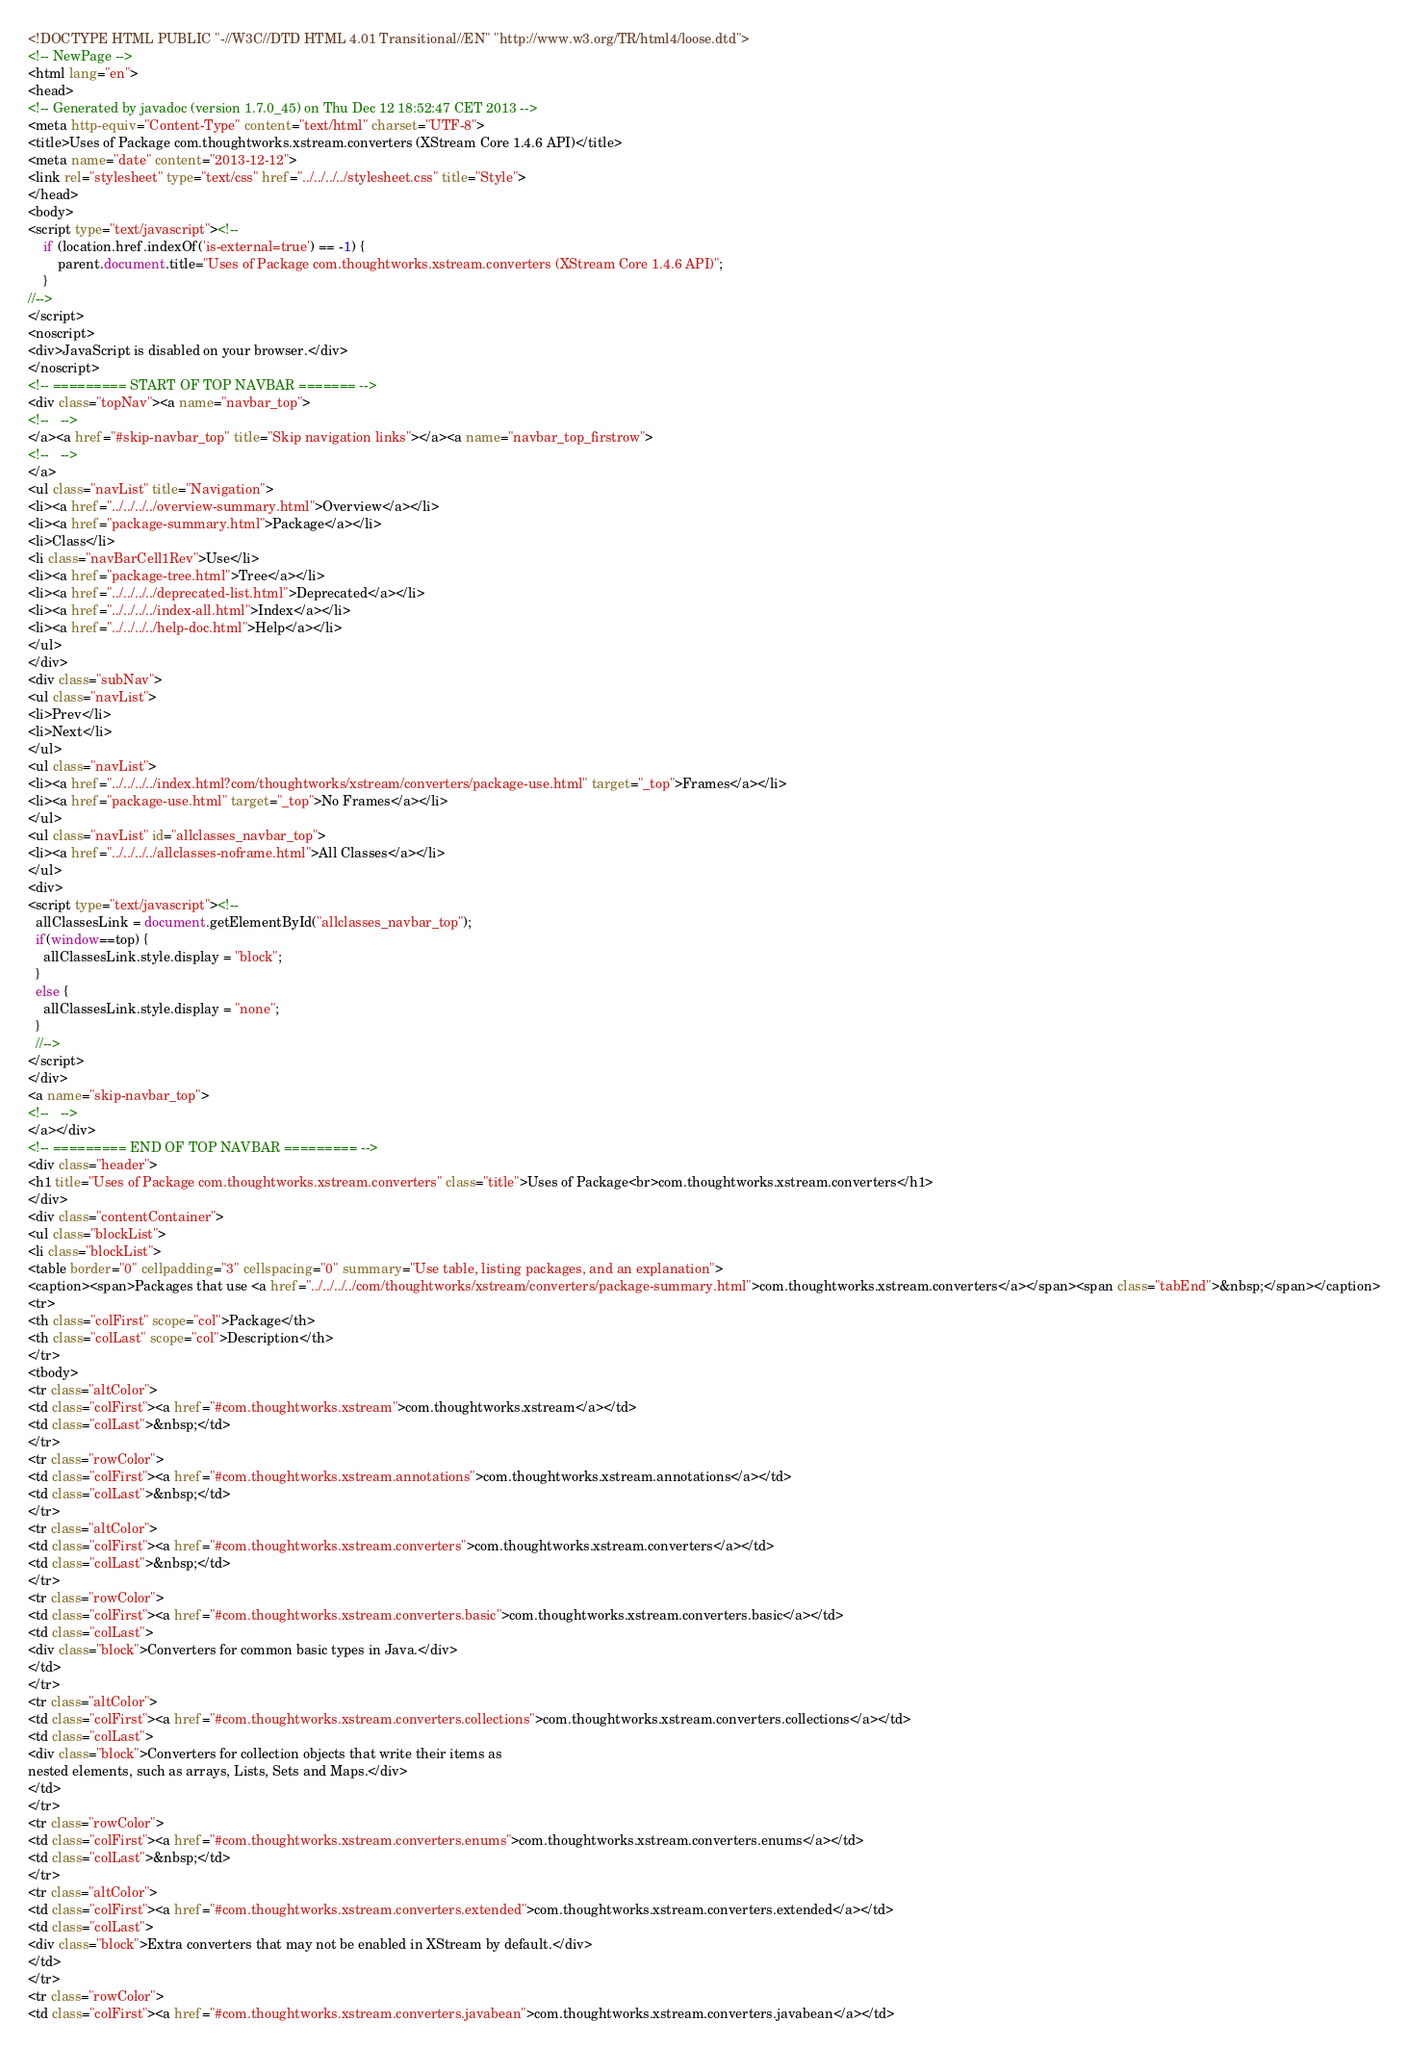Convert code to text. <code><loc_0><loc_0><loc_500><loc_500><_HTML_><!DOCTYPE HTML PUBLIC "-//W3C//DTD HTML 4.01 Transitional//EN" "http://www.w3.org/TR/html4/loose.dtd">
<!-- NewPage -->
<html lang="en">
<head>
<!-- Generated by javadoc (version 1.7.0_45) on Thu Dec 12 18:52:47 CET 2013 -->
<meta http-equiv="Content-Type" content="text/html" charset="UTF-8">
<title>Uses of Package com.thoughtworks.xstream.converters (XStream Core 1.4.6 API)</title>
<meta name="date" content="2013-12-12">
<link rel="stylesheet" type="text/css" href="../../../../stylesheet.css" title="Style">
</head>
<body>
<script type="text/javascript"><!--
    if (location.href.indexOf('is-external=true') == -1) {
        parent.document.title="Uses of Package com.thoughtworks.xstream.converters (XStream Core 1.4.6 API)";
    }
//-->
</script>
<noscript>
<div>JavaScript is disabled on your browser.</div>
</noscript>
<!-- ========= START OF TOP NAVBAR ======= -->
<div class="topNav"><a name="navbar_top">
<!--   -->
</a><a href="#skip-navbar_top" title="Skip navigation links"></a><a name="navbar_top_firstrow">
<!--   -->
</a>
<ul class="navList" title="Navigation">
<li><a href="../../../../overview-summary.html">Overview</a></li>
<li><a href="package-summary.html">Package</a></li>
<li>Class</li>
<li class="navBarCell1Rev">Use</li>
<li><a href="package-tree.html">Tree</a></li>
<li><a href="../../../../deprecated-list.html">Deprecated</a></li>
<li><a href="../../../../index-all.html">Index</a></li>
<li><a href="../../../../help-doc.html">Help</a></li>
</ul>
</div>
<div class="subNav">
<ul class="navList">
<li>Prev</li>
<li>Next</li>
</ul>
<ul class="navList">
<li><a href="../../../../index.html?com/thoughtworks/xstream/converters/package-use.html" target="_top">Frames</a></li>
<li><a href="package-use.html" target="_top">No Frames</a></li>
</ul>
<ul class="navList" id="allclasses_navbar_top">
<li><a href="../../../../allclasses-noframe.html">All Classes</a></li>
</ul>
<div>
<script type="text/javascript"><!--
  allClassesLink = document.getElementById("allclasses_navbar_top");
  if(window==top) {
    allClassesLink.style.display = "block";
  }
  else {
    allClassesLink.style.display = "none";
  }
  //-->
</script>
</div>
<a name="skip-navbar_top">
<!--   -->
</a></div>
<!-- ========= END OF TOP NAVBAR ========= -->
<div class="header">
<h1 title="Uses of Package com.thoughtworks.xstream.converters" class="title">Uses of Package<br>com.thoughtworks.xstream.converters</h1>
</div>
<div class="contentContainer">
<ul class="blockList">
<li class="blockList">
<table border="0" cellpadding="3" cellspacing="0" summary="Use table, listing packages, and an explanation">
<caption><span>Packages that use <a href="../../../../com/thoughtworks/xstream/converters/package-summary.html">com.thoughtworks.xstream.converters</a></span><span class="tabEnd">&nbsp;</span></caption>
<tr>
<th class="colFirst" scope="col">Package</th>
<th class="colLast" scope="col">Description</th>
</tr>
<tbody>
<tr class="altColor">
<td class="colFirst"><a href="#com.thoughtworks.xstream">com.thoughtworks.xstream</a></td>
<td class="colLast">&nbsp;</td>
</tr>
<tr class="rowColor">
<td class="colFirst"><a href="#com.thoughtworks.xstream.annotations">com.thoughtworks.xstream.annotations</a></td>
<td class="colLast">&nbsp;</td>
</tr>
<tr class="altColor">
<td class="colFirst"><a href="#com.thoughtworks.xstream.converters">com.thoughtworks.xstream.converters</a></td>
<td class="colLast">&nbsp;</td>
</tr>
<tr class="rowColor">
<td class="colFirst"><a href="#com.thoughtworks.xstream.converters.basic">com.thoughtworks.xstream.converters.basic</a></td>
<td class="colLast">
<div class="block">Converters for common basic types in Java.</div>
</td>
</tr>
<tr class="altColor">
<td class="colFirst"><a href="#com.thoughtworks.xstream.converters.collections">com.thoughtworks.xstream.converters.collections</a></td>
<td class="colLast">
<div class="block">Converters for collection objects that write their items as
nested elements, such as arrays, Lists, Sets and Maps.</div>
</td>
</tr>
<tr class="rowColor">
<td class="colFirst"><a href="#com.thoughtworks.xstream.converters.enums">com.thoughtworks.xstream.converters.enums</a></td>
<td class="colLast">&nbsp;</td>
</tr>
<tr class="altColor">
<td class="colFirst"><a href="#com.thoughtworks.xstream.converters.extended">com.thoughtworks.xstream.converters.extended</a></td>
<td class="colLast">
<div class="block">Extra converters that may not be enabled in XStream by default.</div>
</td>
</tr>
<tr class="rowColor">
<td class="colFirst"><a href="#com.thoughtworks.xstream.converters.javabean">com.thoughtworks.xstream.converters.javabean</a></td></code> 